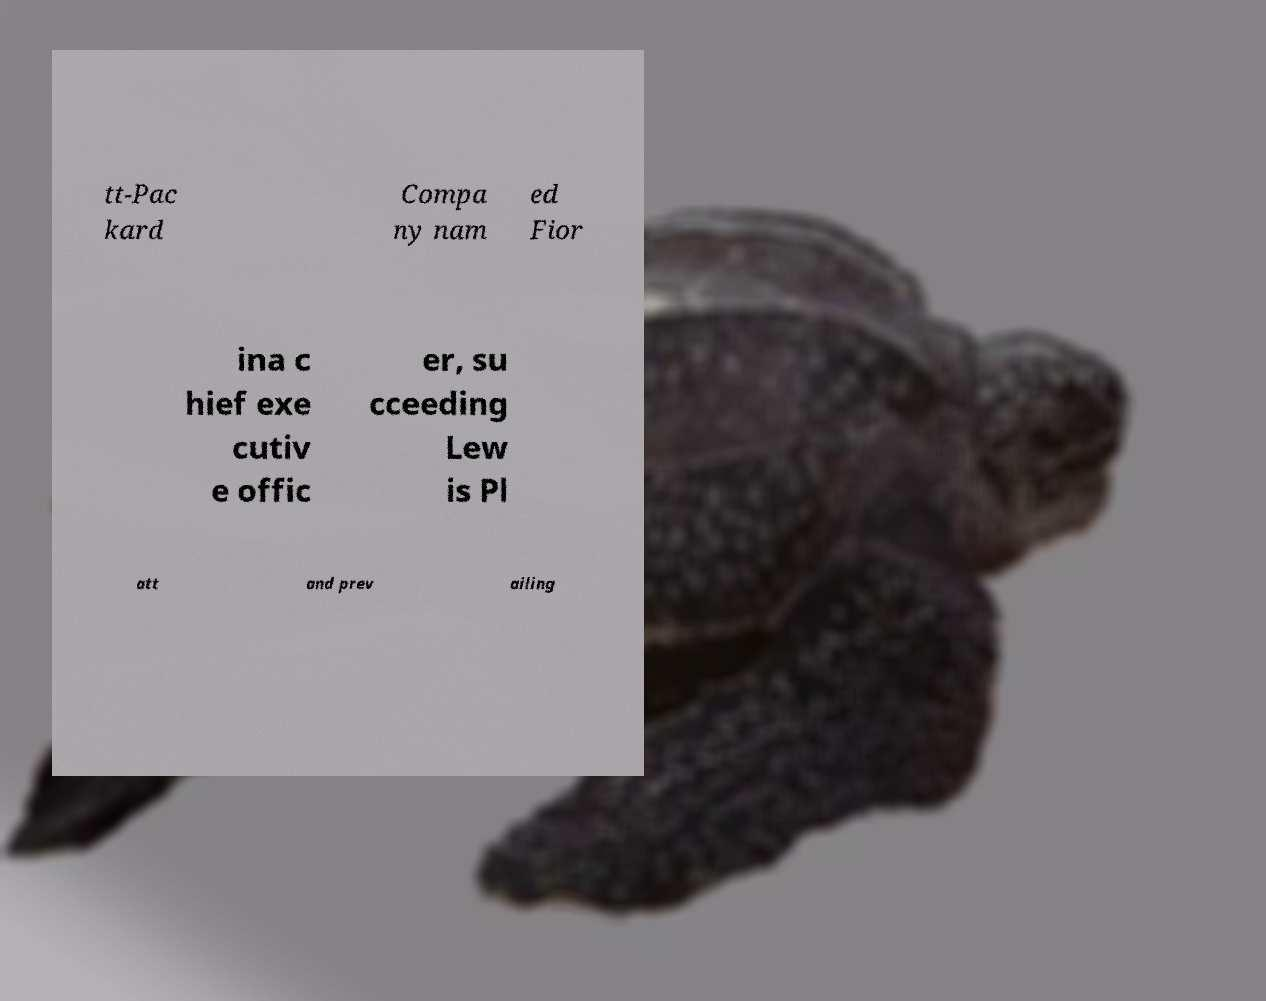There's text embedded in this image that I need extracted. Can you transcribe it verbatim? tt-Pac kard Compa ny nam ed Fior ina c hief exe cutiv e offic er, su cceeding Lew is Pl att and prev ailing 